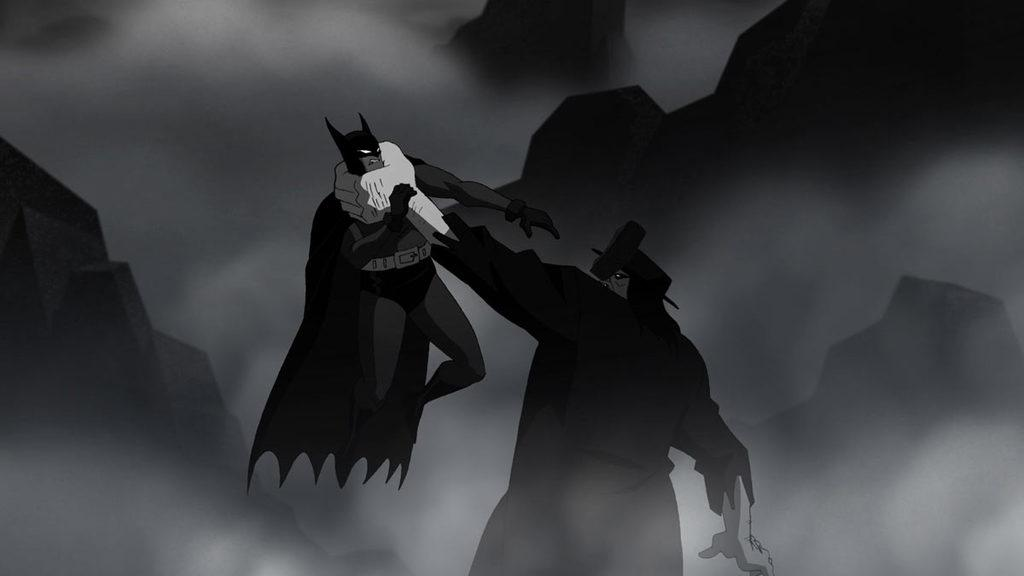What is the main subject of the image? There is a person standing in the center of the image. What is the person in the image doing? The person is holding another person. What can be seen in the background of the image? There are mountains in the background of the image. How many seats are visible in the image? There are no seats visible in the image. Can you see any deer in the image? There are no deer present in the image. 